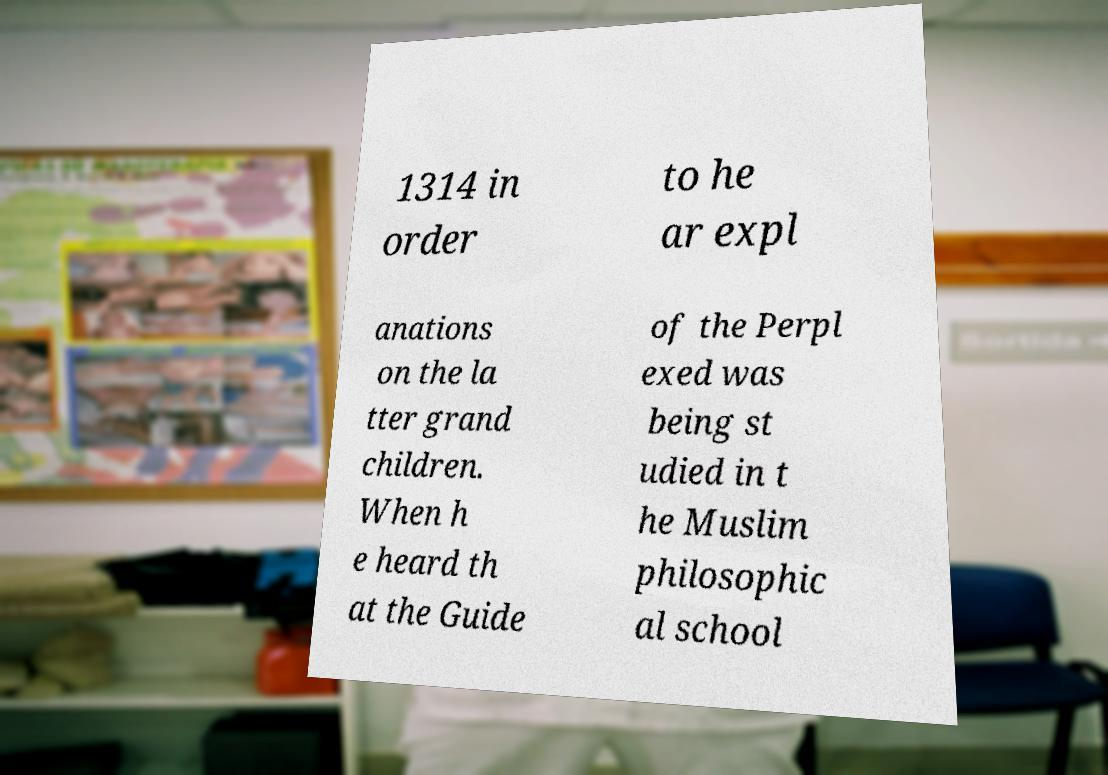What messages or text are displayed in this image? I need them in a readable, typed format. 1314 in order to he ar expl anations on the la tter grand children. When h e heard th at the Guide of the Perpl exed was being st udied in t he Muslim philosophic al school 